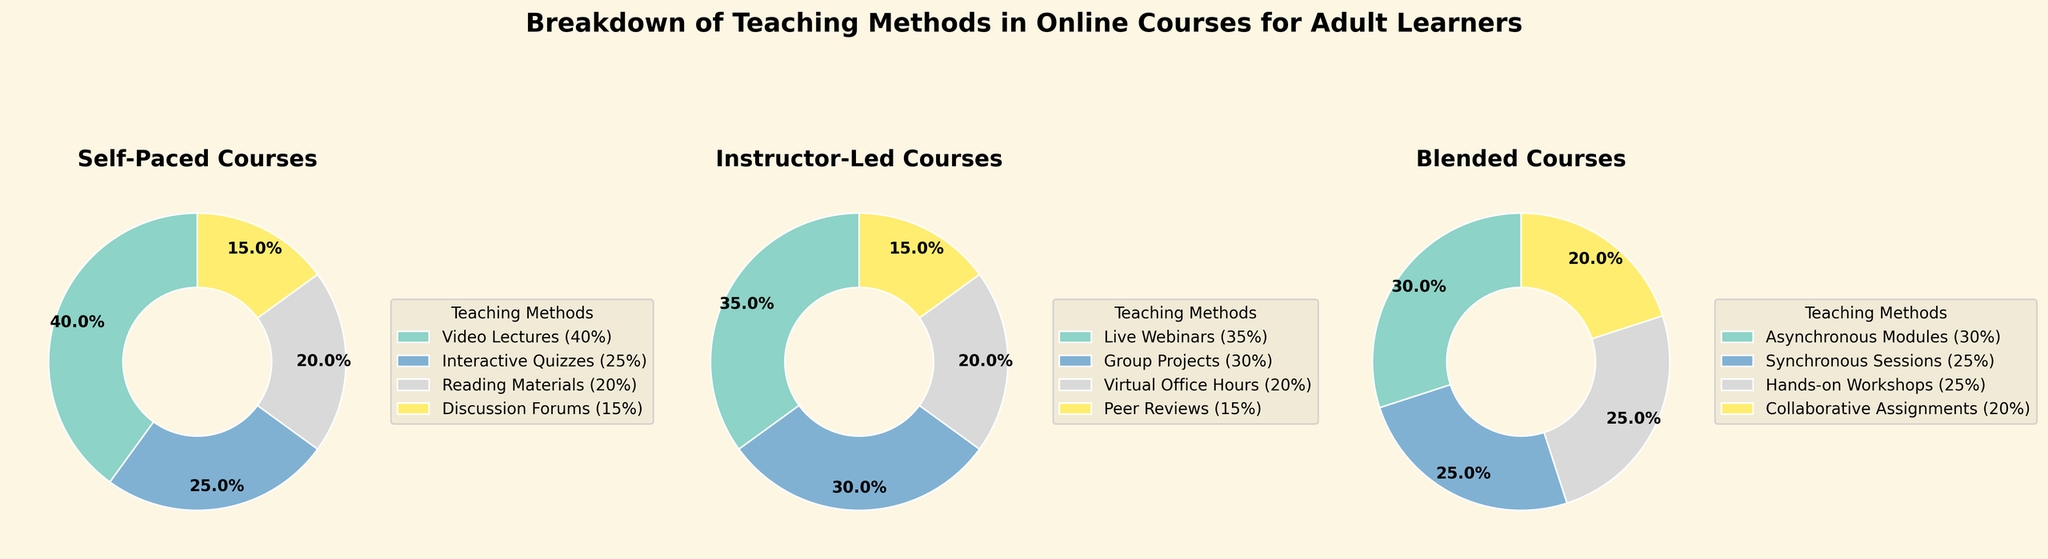Which course type has the highest percentage of Video Lectures? In the figure, the "Self-Paced" courses category has a segment labeled "Video Lectures (40%)", which is higher than any similar segment in other course types.
Answer: Self-Paced What is the total percentage of non-collaborative teaching methods in Blended courses? "Blended" courses have "Asynchronous Modules (30%)", "Synchronous Sessions (25%)", and "Hands-on Workshops (25%)". The sum of these percentages is 30% + 25% + 25% = 80%.
Answer: 80% Which teaching method appears in all three course types? By checking each pie chart, "Self-Paced" has no common method with both "Instructor-Led" and "Blended". Therefore, no teaching method is common across all three course types.
Answer: None Which course type has the lowest percentage for any single teaching method, and what is that method? In "Self-Paced" courses, "Discussion Forums" have the smallest segment labeled as 15%, compared to the smallest segments in other course types.
Answer: Self-Paced, Discussion Forums Compare the combined percentages of Interactive Quizzes in Self-Paced courses and Peer Reviews in Instructor-Led courses. The "Interactive Quizzes" segment in Self-Paced courses is 25%, and "Peer Reviews" in Instructor-Led courses is 15%. The combined percentage is 25% + 15% = 40%.
Answer: 40% Which course type has the most evenly distributed teaching methods? In "Blended" courses, all methods are relatively close in percentage: Asynchronous Modules (30%), Synchronous Sessions (25%), Hands-on Workshops (25%), Collaborative Assignments (20%). The differences are smaller compared to other types.
Answer: Blended What is the difference in percentage between the most used teaching method in Instructor-Led courses and the least used teaching method in Self-Paced courses? The highest percentage method in "Instructor-Led" courses is "Live Webinars" with 35%, and the lowest in "Self-Paced" is "Discussion Forums" with 15%. The difference is 35% - 15% = 20%.
Answer: 20% What's the average percentage of Group Projects and Virtual Office Hours in Instructor-Led courses? Group Projects make up 30% and Virtual Office Hours make up 20%. The average is (30% + 20%)/2 = 25%.
Answer: 25% Which teaching method has the smallest representation among all course types? "Discussion Forums" in "Self-Paced" courses are the smallest segment at 15%, and no other method in other course types is smaller.
Answer: Discussion Forums 